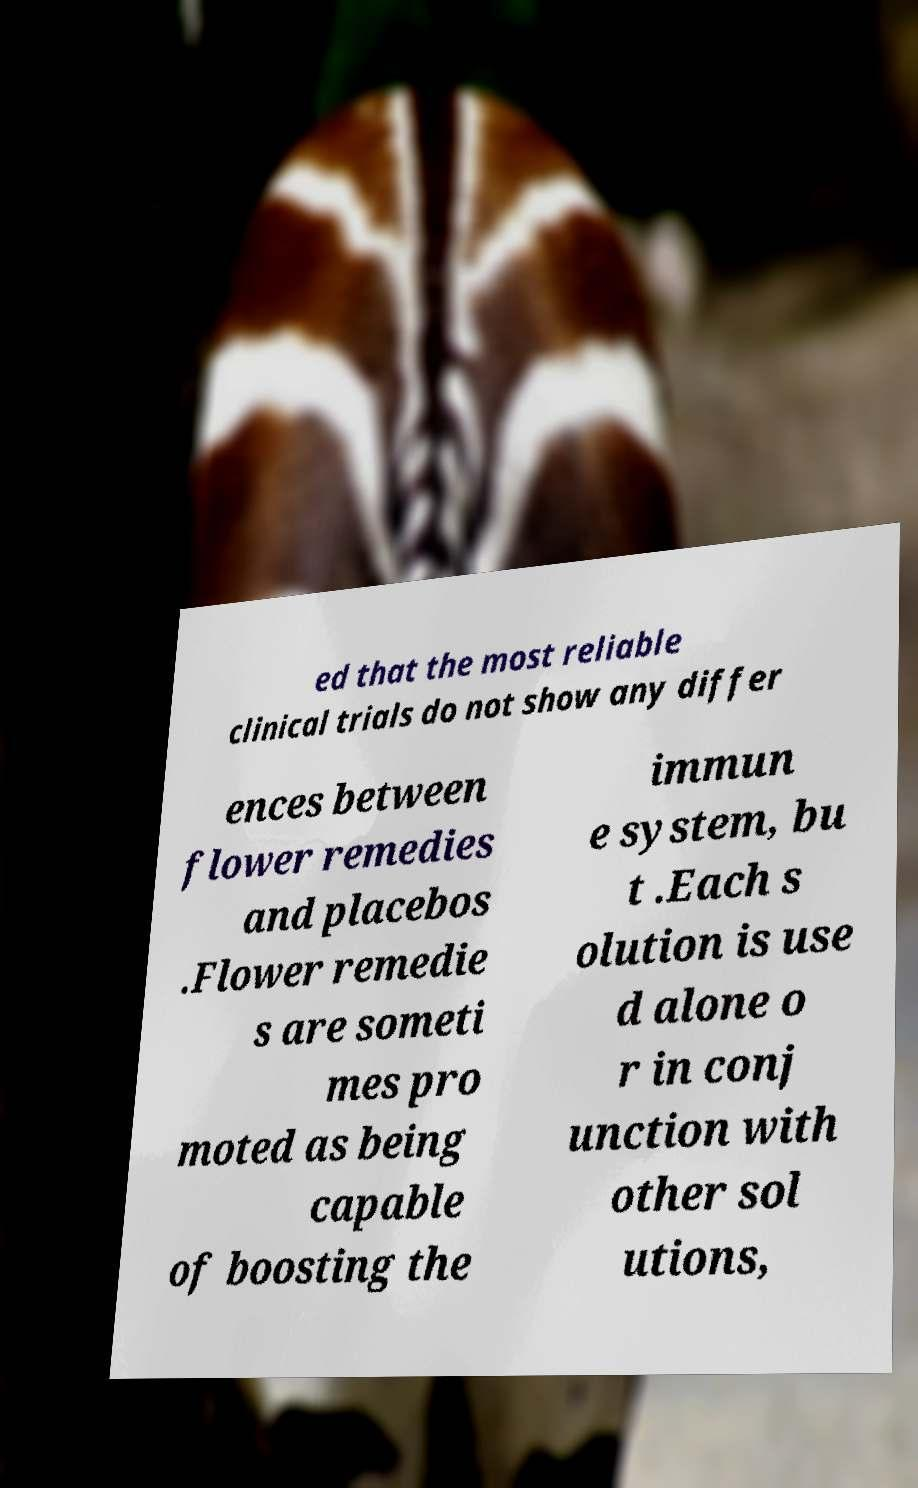I need the written content from this picture converted into text. Can you do that? ed that the most reliable clinical trials do not show any differ ences between flower remedies and placebos .Flower remedie s are someti mes pro moted as being capable of boosting the immun e system, bu t .Each s olution is use d alone o r in conj unction with other sol utions, 